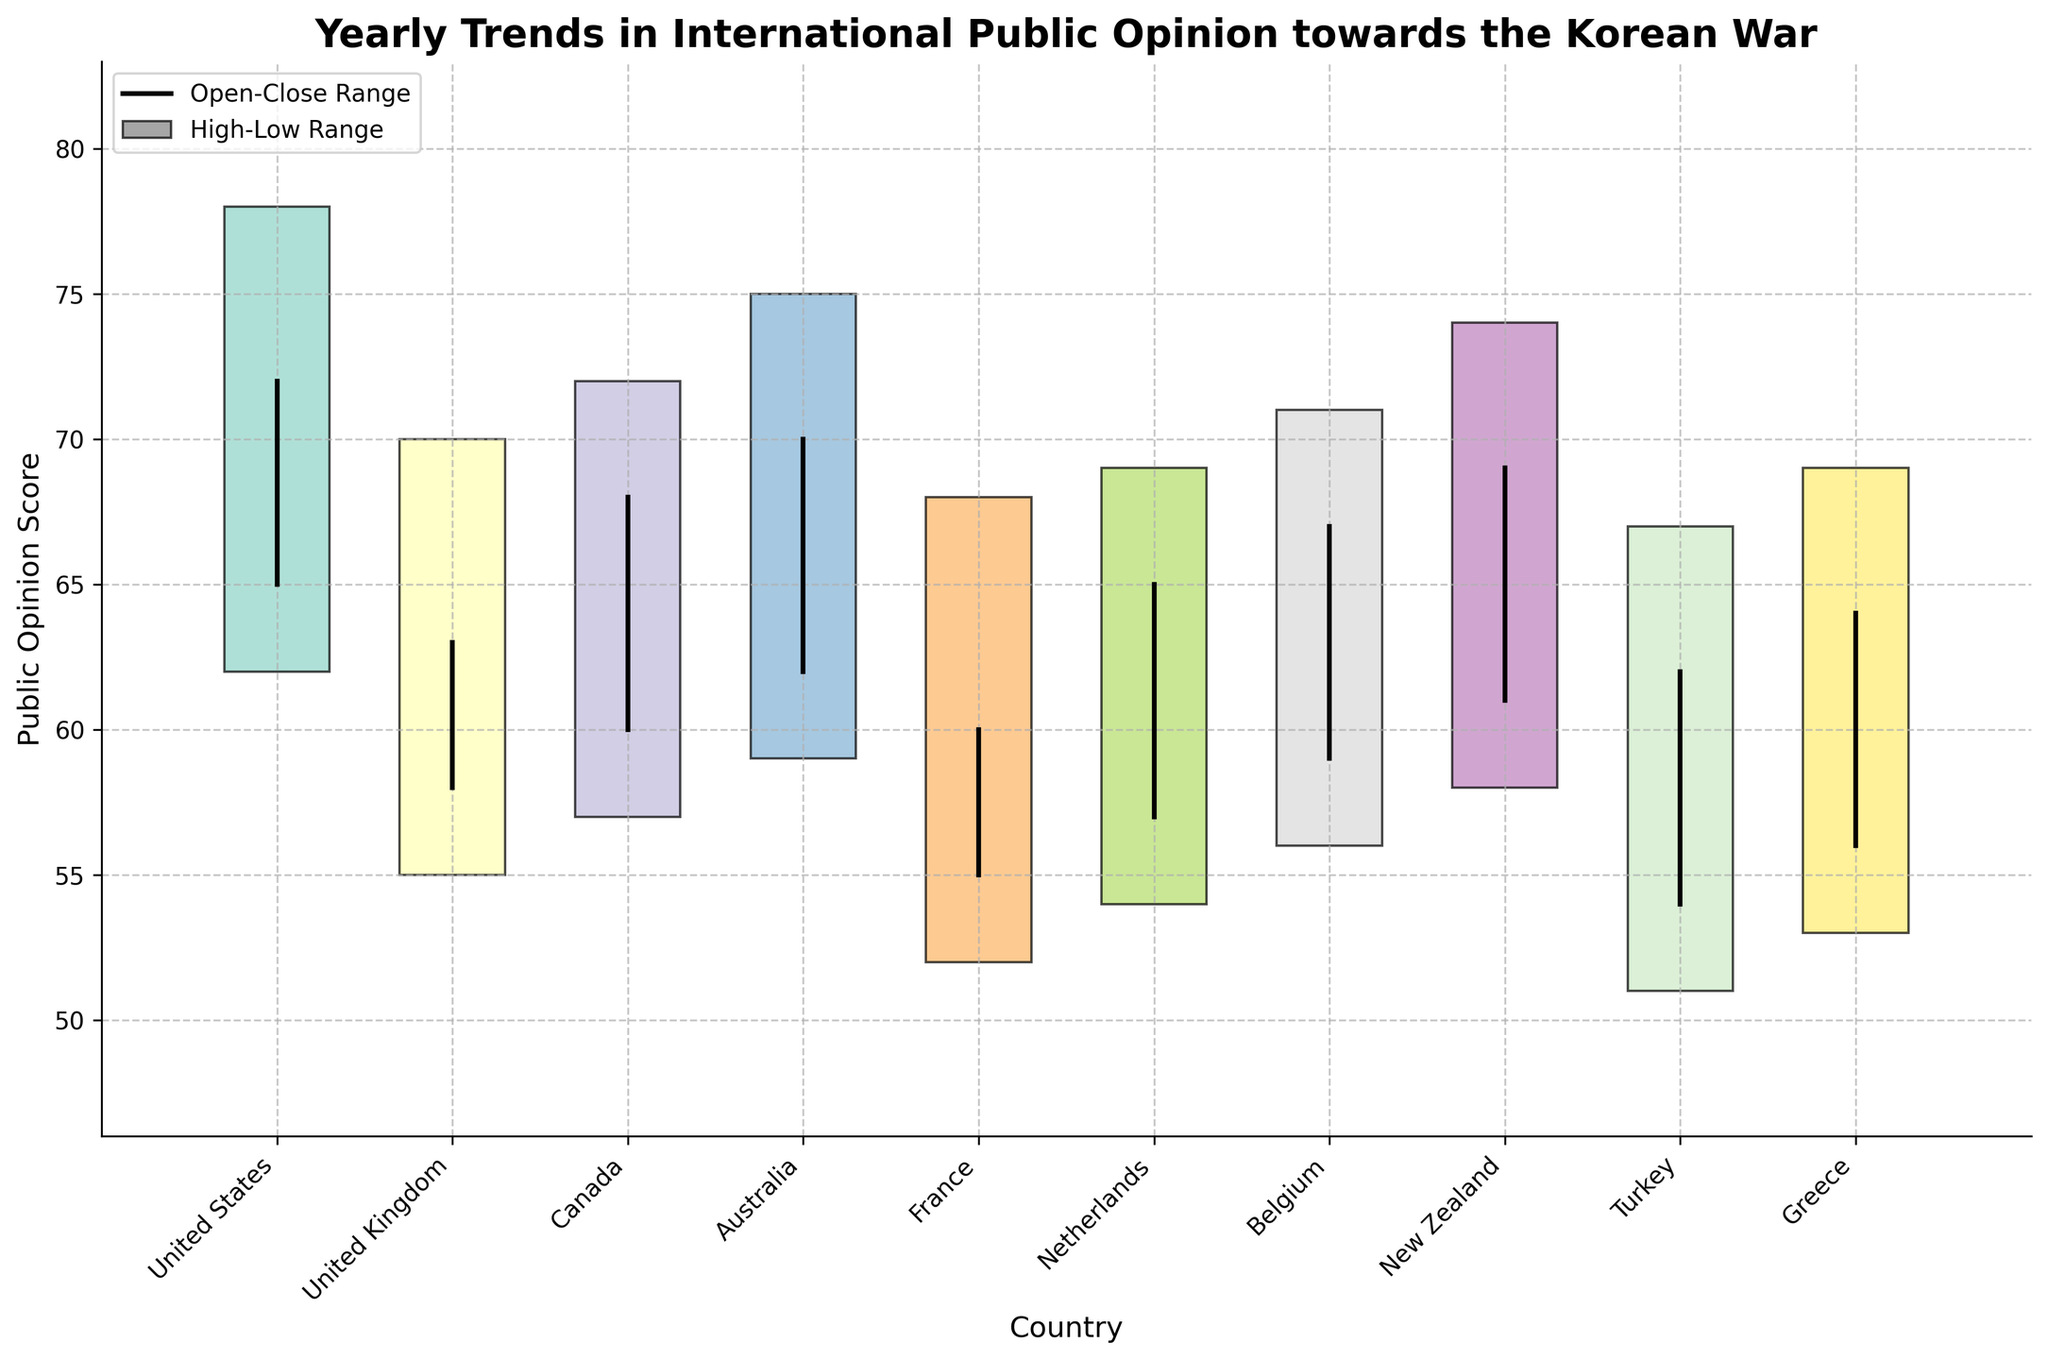what is the title of the figure? The title is usually displayed at the top of the figure. In this figure, it is: "Yearly Trends in International Public Opinion towards the Korean War".
Answer: Yearly Trends in International Public Opinion towards the Korean War what is the range of public opinion scores for New Zealand? We can see from the figure that for New Zealand, the highest public opinion score is the high value, and the lowest is the low value.
Answer: 58-74 Which country had the highest public opinion score and what was that score? By looking at the top values (highs) of each bar, we can identify that the United States had the highest score of 78 in 1950.
Answer: United States, 78 What was the lowest public opinion score recorded, and which country did it occur in? The lowest public opinion score is represented by the lowest point (low) in the figure. France had the lowest score of 52 in 1954.
Answer: France, 52 Which countries had a close value higher than their open value? We need to compare the open and close values for each country. The countries with a close value higher than their open value are the United States, Canada, Australia, Netherlands, Belgium, and New Zealand.
Answer: United States, Canada, Australia, Netherlands, Belgium, New Zealand On which axis and how are countries represented in the chart? In the chart, countries are displayed along the x-axis, each labeled at the ticks with a respective name.
Answer: x-axis, labeled ticks Calculate the average high public opinion score of all countries. To find the average high value, sum all the high scores (78 + 70 + 72 + 75 + 68 + 69 + 71 + 74 + 67 + 69) and divide by 10 (number of countries). The total sum is 713, so the average is 713/10 = 71.3.
Answer: 71.3 Which country had the smallest difference between its high and low public opinion scores? We calculate the difference for each country and compare them: United States (16), United Kingdom (15), Canada (15), Australia (16), France (16), Netherlands (15), Belgium (15), New Zealand (16), Turkey (16), Greece (16). The smallest difference is 15, shared by the United Kingdom, Canada, Netherlands, and Belgium.
Answer: United Kingdom, Canada, Netherlands, Belgium 